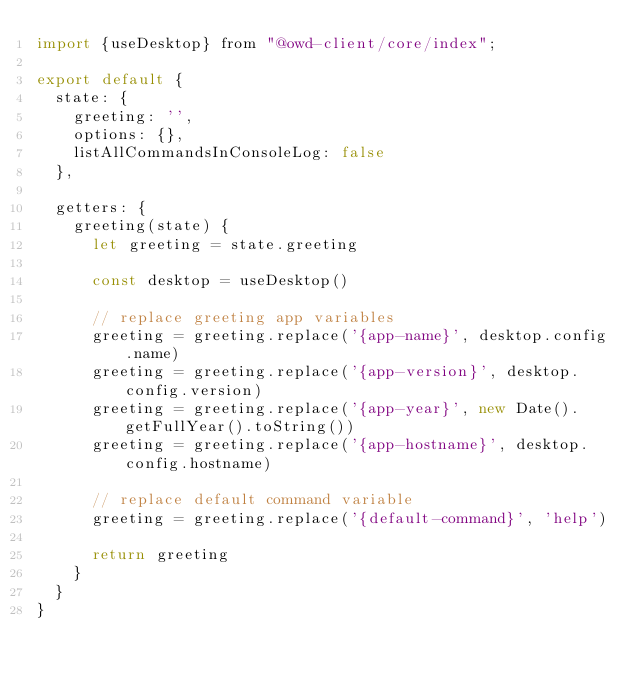<code> <loc_0><loc_0><loc_500><loc_500><_JavaScript_>import {useDesktop} from "@owd-client/core/index";

export default {
  state: {
    greeting: '',
    options: {},
    listAllCommandsInConsoleLog: false
  },

  getters: {
    greeting(state) {
      let greeting = state.greeting

      const desktop = useDesktop()

      // replace greeting app variables
      greeting = greeting.replace('{app-name}', desktop.config.name)
      greeting = greeting.replace('{app-version}', desktop.config.version)
      greeting = greeting.replace('{app-year}', new Date().getFullYear().toString())
      greeting = greeting.replace('{app-hostname}', desktop.config.hostname)

      // replace default command variable
      greeting = greeting.replace('{default-command}', 'help')

      return greeting
    }
  }
}</code> 